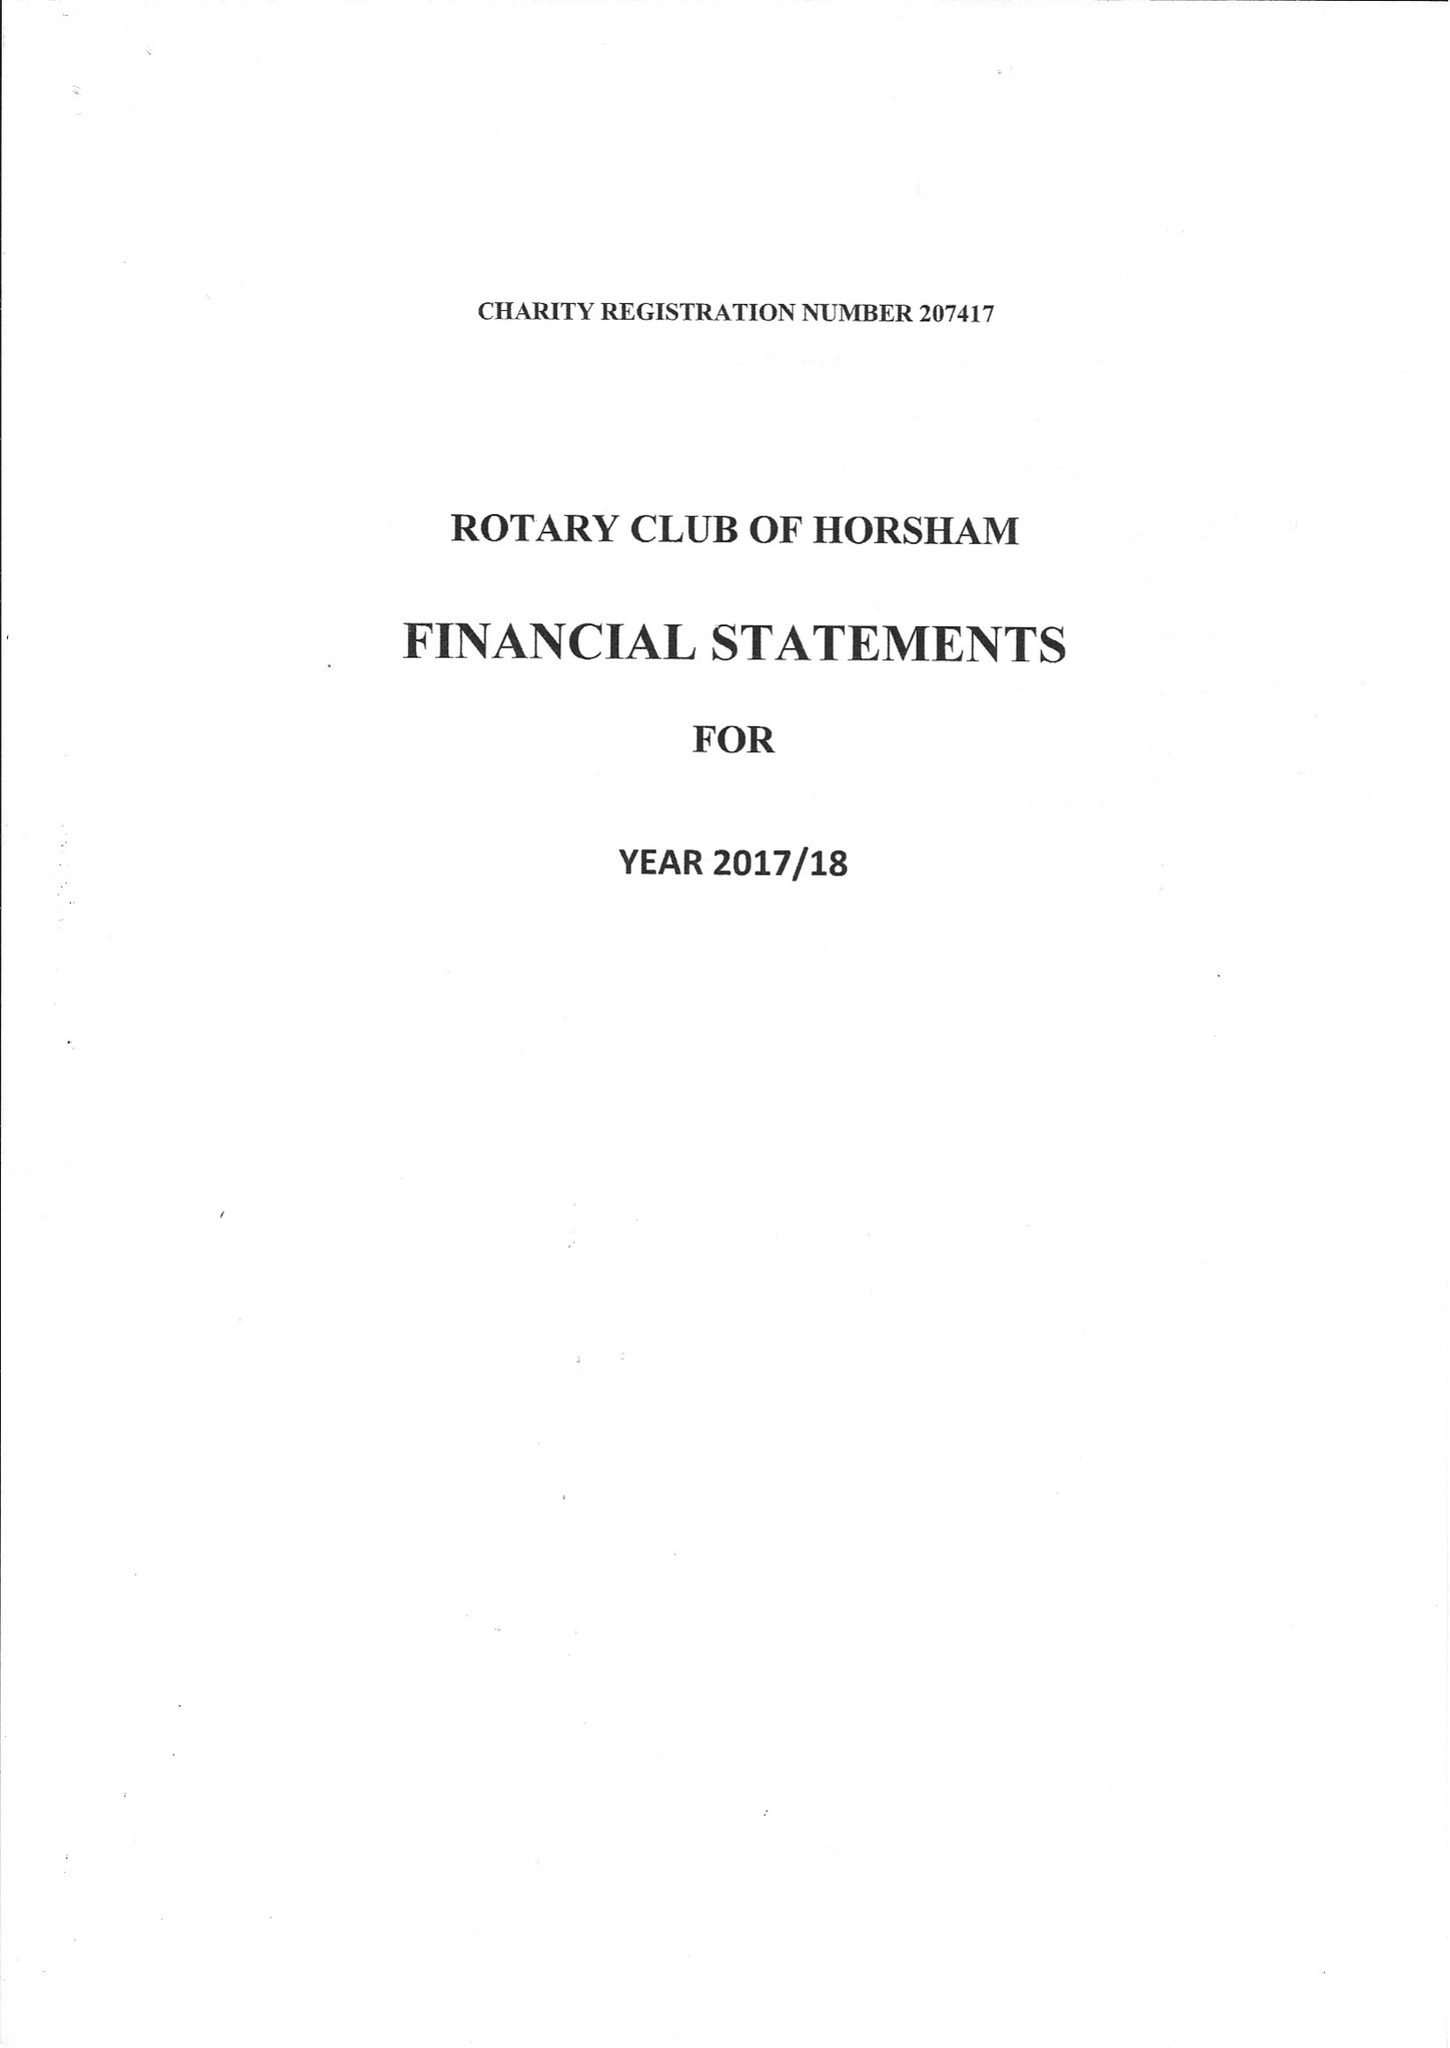What is the value for the income_annually_in_british_pounds?
Answer the question using a single word or phrase. 31233.00 